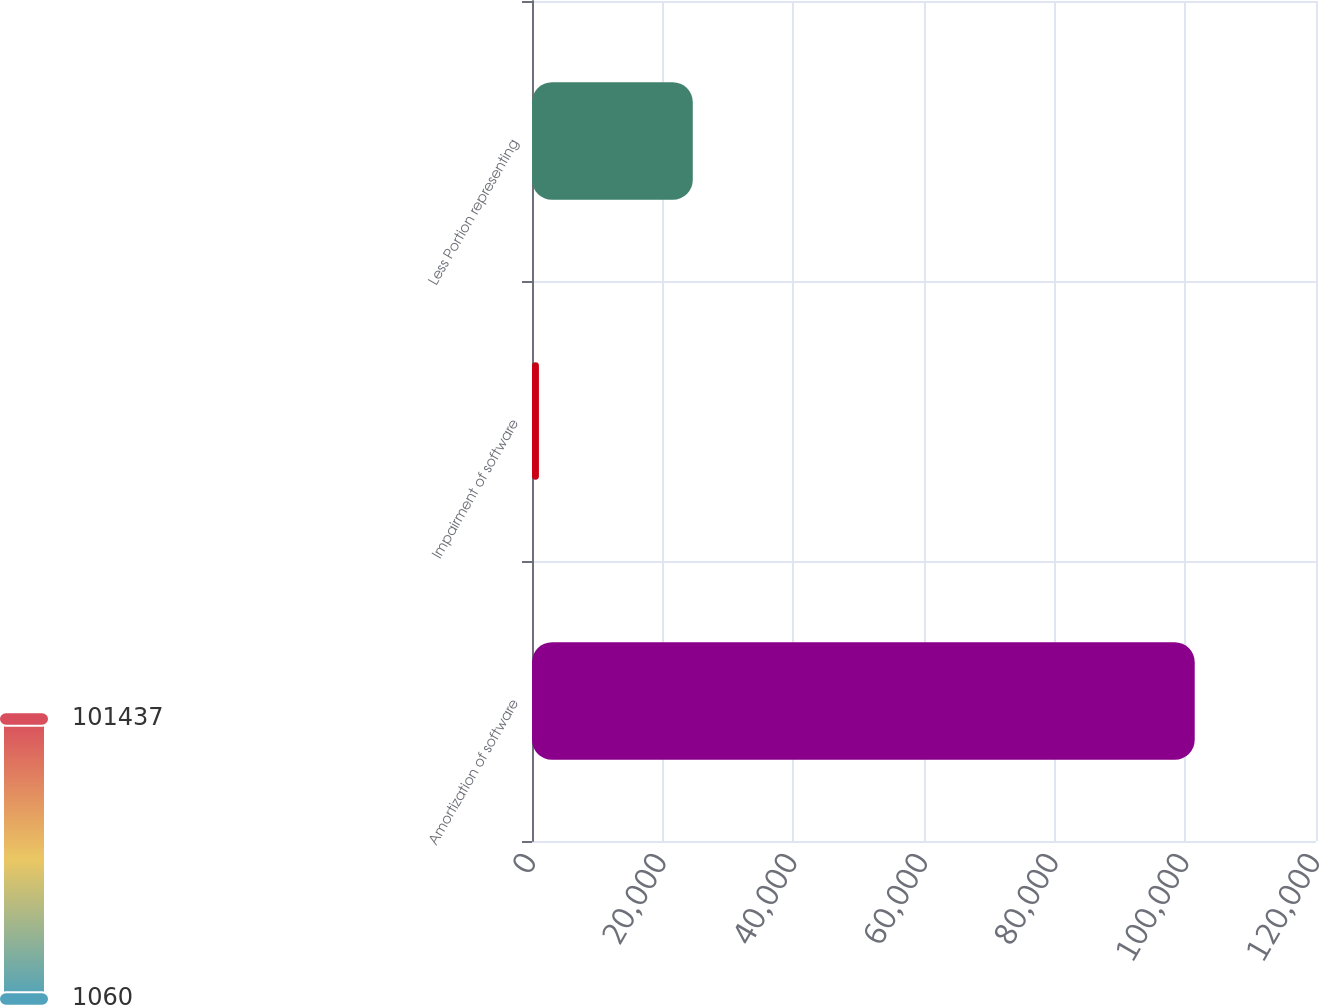<chart> <loc_0><loc_0><loc_500><loc_500><bar_chart><fcel>Amortization of software<fcel>Impairment of software<fcel>Less Portion representing<nl><fcel>101437<fcel>1060<fcel>24610<nl></chart> 